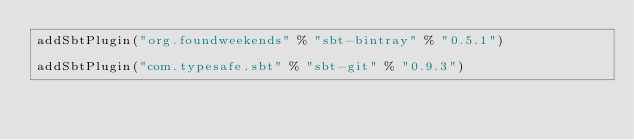Convert code to text. <code><loc_0><loc_0><loc_500><loc_500><_Scala_>addSbtPlugin("org.foundweekends" % "sbt-bintray" % "0.5.1")

addSbtPlugin("com.typesafe.sbt" % "sbt-git" % "0.9.3")
</code> 